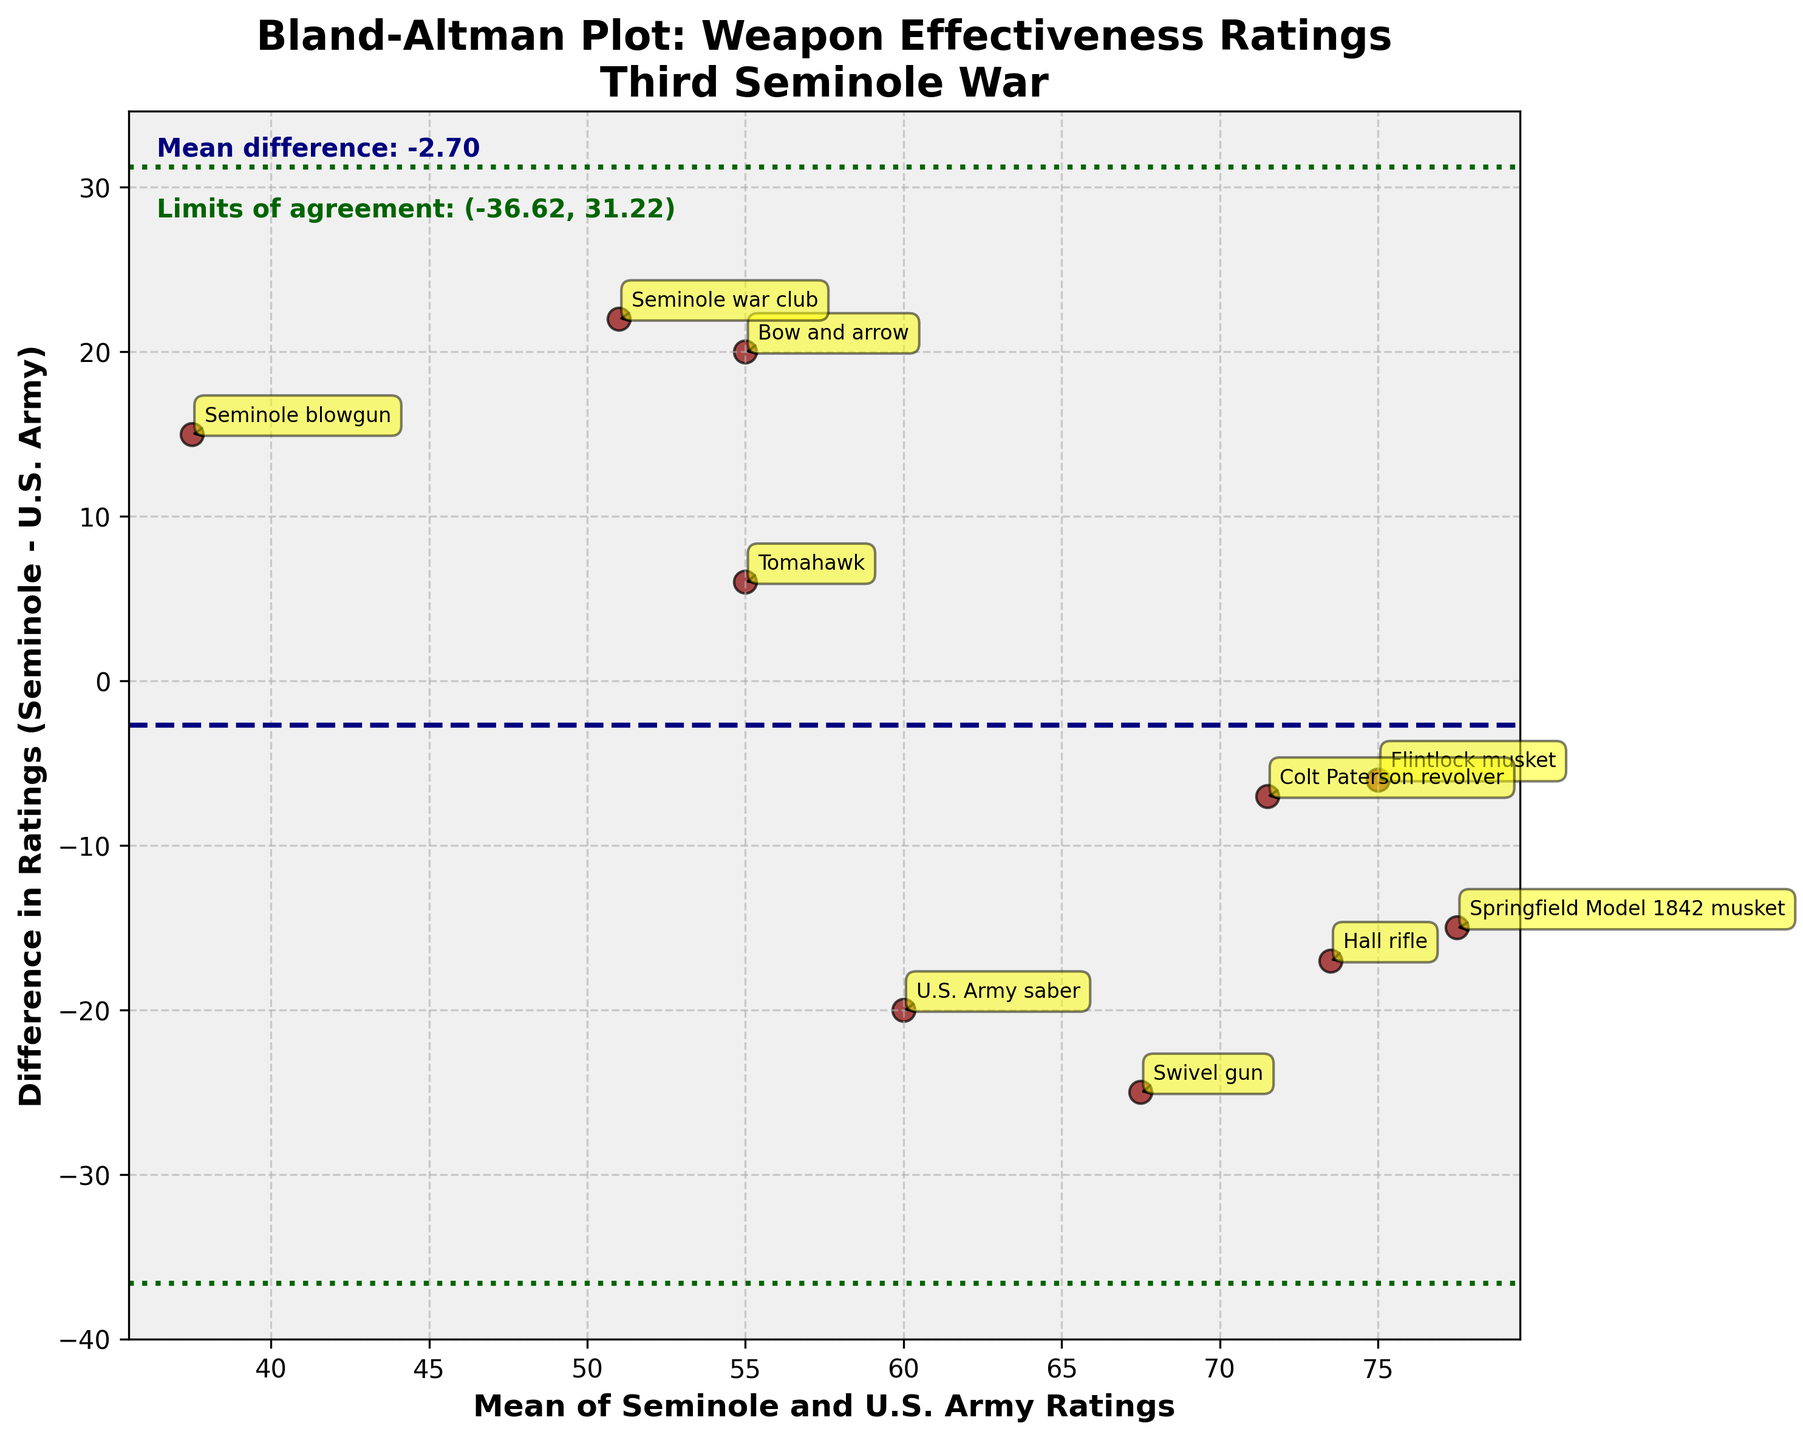What does the title of the figure indicate? The title of the figure, "Bland-Altman Plot: Weapon Effectiveness Ratings\nThird Seminole War," informs us that the plot is a Bland-Altman plot comparing weapon effectiveness ratings between Seminole and U.S. Army arsenals during the Third Seminole War.
Answer: Bland-Altman Plot: Weapon Effectiveness Ratings\nThird Seminole War How many weapons were compared in this figure? By counting the number of data points annotated with weapon names, we see that there are 10 weapons compared in the figure.
Answer: 10 What does the horizontal line in dark blue represent? The horizontal line in dark blue represents the mean difference between the weapon effectiveness ratings of the Seminole and U.S. Army arsenals.
Answer: Mean difference What are the limits of agreement shown in the plot? The limits of agreement are illustrated by two horizontal green dashed lines. According to the plot, they are approximately -20.5 and 33.5.
Answer: -20.5 and 33.5 Which weapon shows the greatest positive difference in effectiveness ratings between Seminole and U.S. Army? From the plot, the Swivel gun shows the greatest positive difference, marked far above the horizontal line at around -25 on the y-axis.
Answer: Swivel gun What is the mean effectiveness rating for the Flintlock musket according to the plot? The mean effectiveness rating for the Flintlock musket is calculated as (72+78)/2, which is 75.
Answer: 75 Which weapon shows a similar effectiveness rating (mean rating) for both Seminole and U.S. Army? The Tomahawk shows a similar effectiveness rating for both Seminole and U.S. Army, as it lies close to the zero line on the y-axis.
Answer: Tomahawk Is the Springfield Model 1842 musket rated higher by the U.S. Army or the Seminoles? The Springfield Model 1842 musket has a negative difference (Seminole - U.S. Army), indicating it is rated higher by the U.S. Army.
Answer: U.S. Army Which weapon has the lowest mean rating of all compared weapons? Based on the figure, the Seminole blowgun has the lowest mean rating, as its coordinates appear lowest on the x-axis.
Answer: Seminole blowgun Do the majority of weapons fall within the limits of agreement? By observing the distribution of data points, we can conclude that most weapons fall within the horizontal lines representing the limits of agreement.
Answer: Yes 